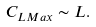Convert formula to latex. <formula><loc_0><loc_0><loc_500><loc_500>C _ { L M a x } \sim L .</formula> 